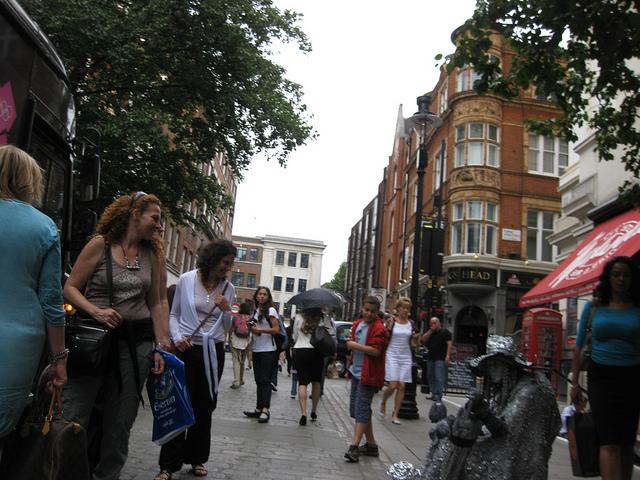What are most of the people looking at?
Give a very brief answer. Statue. What is the man wearing on his wrist?
Concise answer only. Watch. Are there more women or men in the picture?
Keep it brief. Women. How many people using an umbrella?
Answer briefly. 1. How many people are there?
Short answer required. 10. Which people are more likely to be tourists?
Give a very brief answer. All of them. What are the people watching?
Answer briefly. Street performer. 